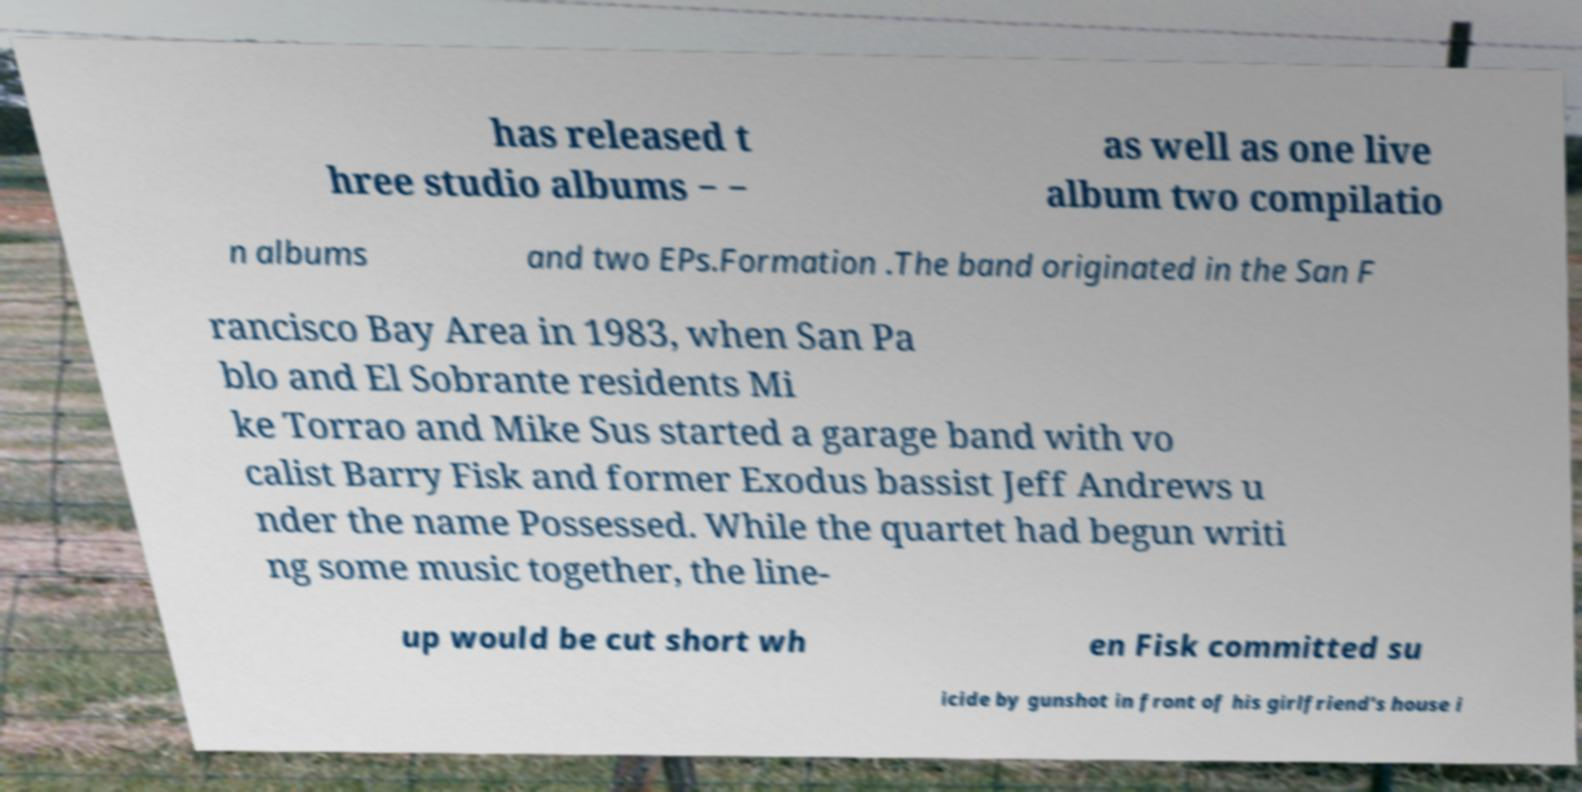Please read and relay the text visible in this image. What does it say? has released t hree studio albums − − as well as one live album two compilatio n albums and two EPs.Formation .The band originated in the San F rancisco Bay Area in 1983, when San Pa blo and El Sobrante residents Mi ke Torrao and Mike Sus started a garage band with vo calist Barry Fisk and former Exodus bassist Jeff Andrews u nder the name Possessed. While the quartet had begun writi ng some music together, the line- up would be cut short wh en Fisk committed su icide by gunshot in front of his girlfriend's house i 